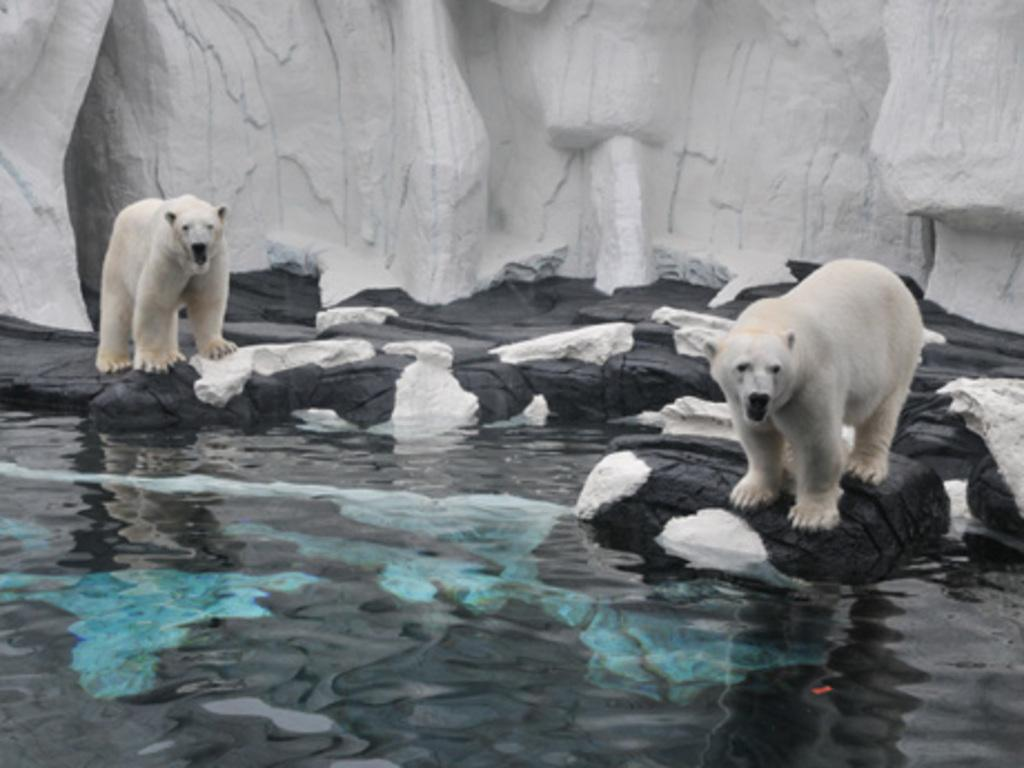How many polar bears are in the image? There are two polar bears in the image. What are the polar bears standing on? The polar bears are standing on stones. Where are the stones located in relation to the water? The stones are beside the water. What type of structure is visible in the image? There is a stone wall in the image. How is the stone wall affected by the weather? The stone wall is covered with snow. What is the income of the polar bears in the image? There is no information about the income of the polar bears in the image, as they are wild animals and do not have an income. 